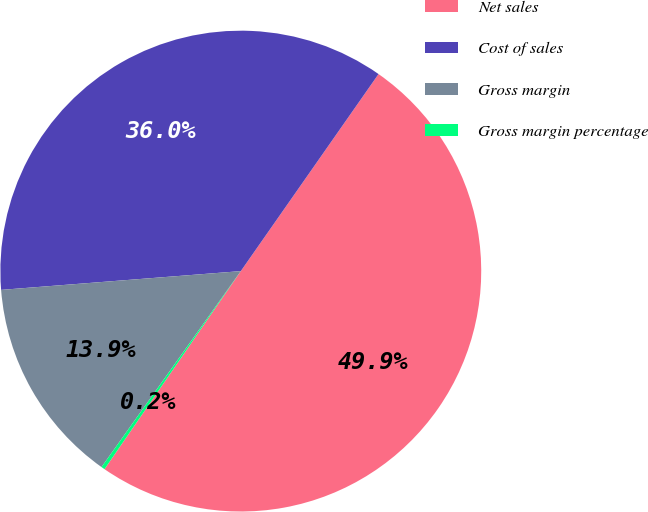<chart> <loc_0><loc_0><loc_500><loc_500><pie_chart><fcel>Net sales<fcel>Cost of sales<fcel>Gross margin<fcel>Gross margin percentage<nl><fcel>49.88%<fcel>35.95%<fcel>13.92%<fcel>0.24%<nl></chart> 